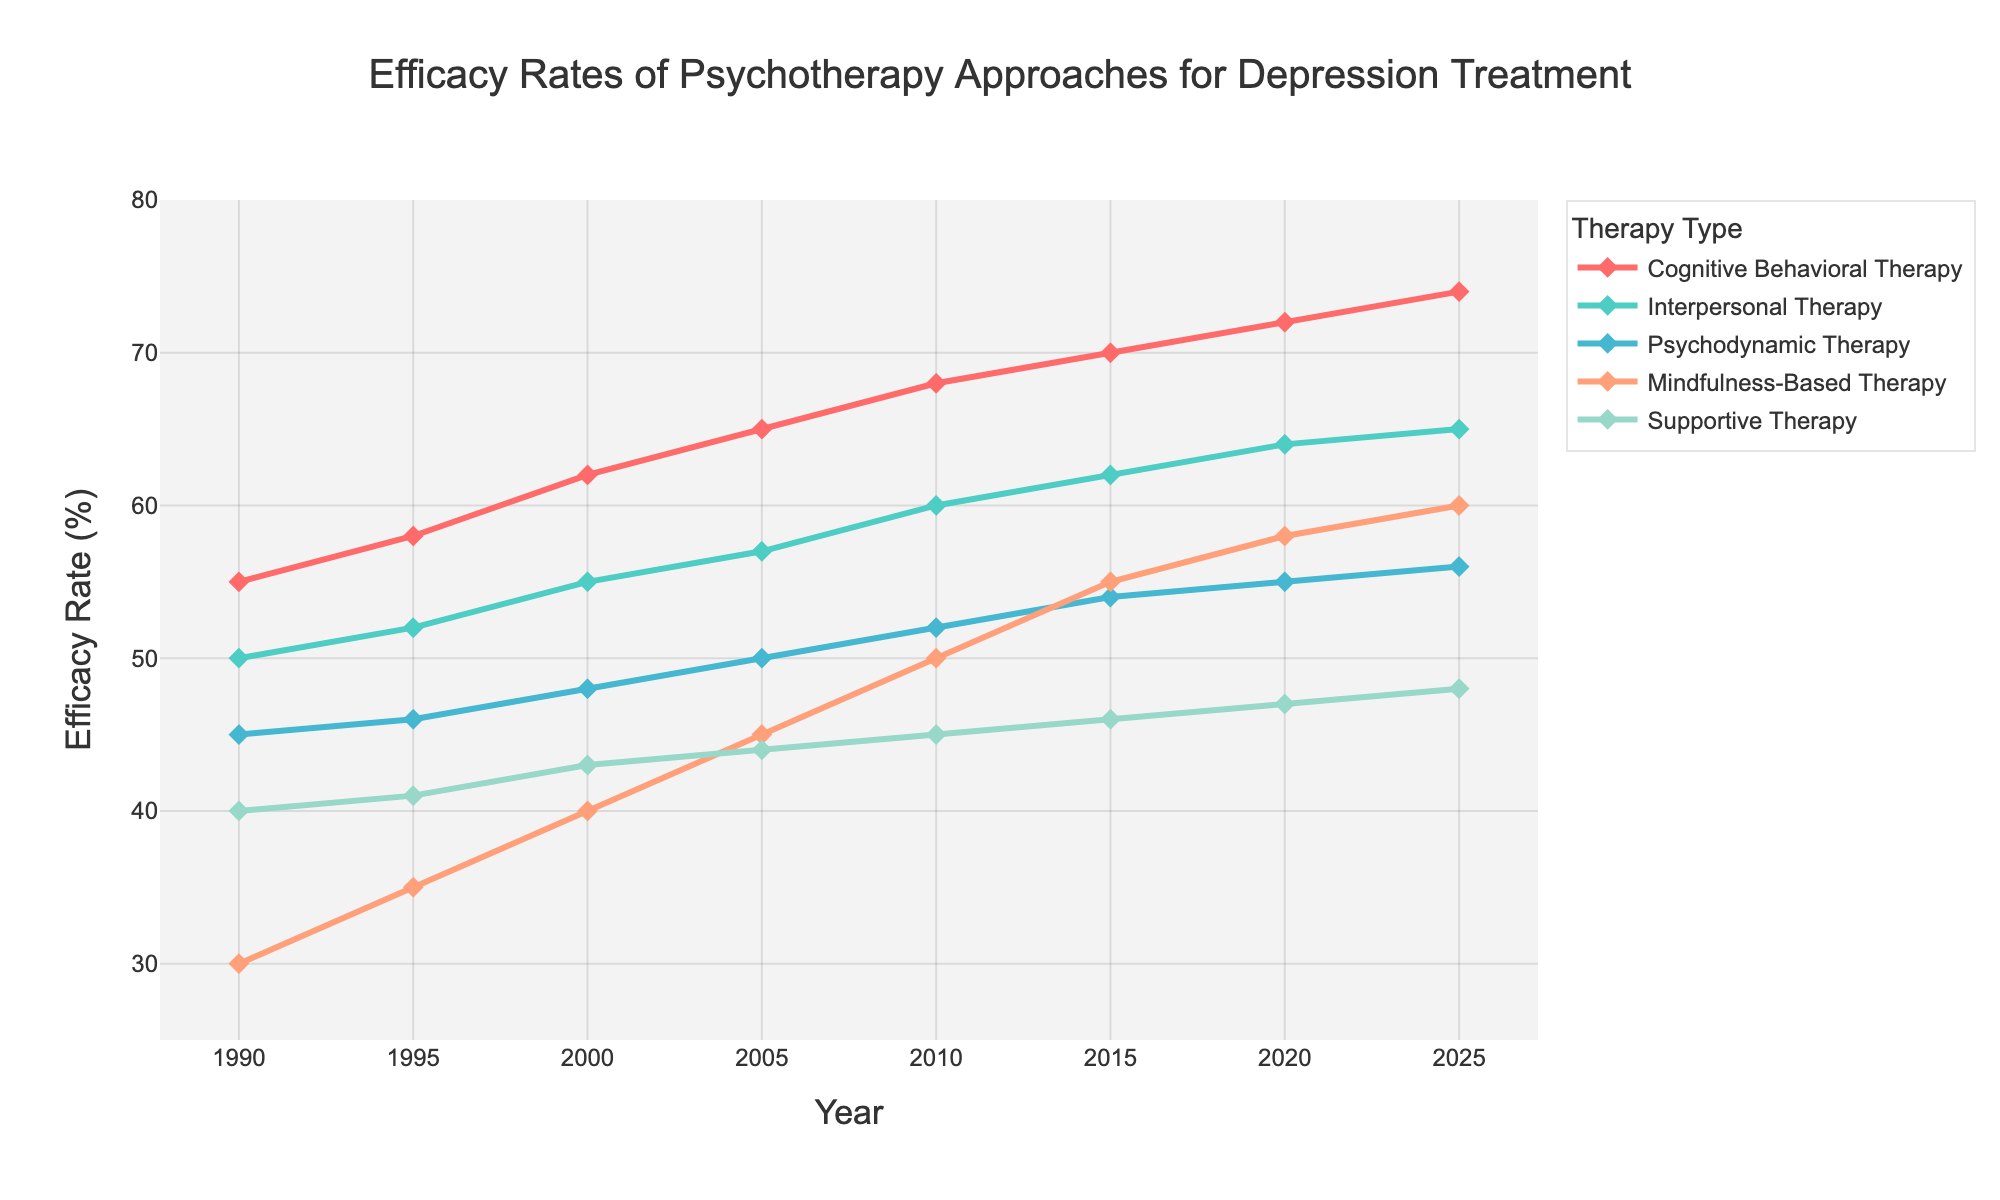What's the average efficacy rate of Cognitive Behavioral Therapy (CBT) over the entire period? First, sum up the efficacy rates of CBT from all the years: 55 + 58 + 62 + 65 + 68 + 70 + 72 + 74 = 524. Then, divide the total by the number of data points: 524 / 8 = 65.5
Answer: 65.5 Which year shows the highest efficacy rate for Mindfulness-Based Therapy? Look at the line for Mindfulness-Based Therapy and identify the peak point which corresponds to the year 2025 with an efficacy rate of 60%.
Answer: 2025 How does the efficacy rate of Interpersonal Therapy in 2000 compare with Psychodynamic Therapy's rate in the same year? Observe the values for Interpersonal Therapy and Psychodynamic Therapy in the year 2000. Interpersonal Therapy is at 55% while Psychodynamic Therapy is at 48%. Interpersonal Therapy is higher.
Answer: Interpersonal Therapy is higher in 2000 Between 1990 and 2025, how much did the efficacy rate of Supportive Therapy increase? Subtract the efficacy rate of Supportive Therapy in 1990 (40%) from that in 2025 (48%): 48 - 40 = 8%.
Answer: 8% In which period did Cognitive Behavioral Therapy see the most significant increase in efficacy? Observe the line representing Cognitive Behavioral Therapy and find the period with the steepest slope. The period from 1990 to 2025 shows a steady increase from 55% to 74%, with the highest increase of 10% happening from 2010 (68%) to 2020 (72%).
Answer: 2010 to 2015 If you average the efficacy rates of 2010 for all therapies, what is the value? Sum the efficacy rates of all therapies in 2010: 68 (CBT) + 60 (Interpersonal) + 52 (Psychodynamic) + 50 (Mindfulness) + 45 (Supportive) = 275. Divide by the number of therapies (5): 275 / 5 = 55%.
Answer: 55% Which therapy has shown consistent improvement without any decline from 1990 to 2025? Observe the lines of all therapies and find the one that continuously increases. Cognitive Behavioral Therapy consistently improves from 1990 to 2025.
Answer: Cognitive Behavioral Therapy Is there any year where Cognitive Behavioral Therapy and Mindfulness-Based Therapy have equal efficacy rates? Compare the values of both therapies year by year. There are no years where their efficacy rates are equal.
Answer: No How does the efficacy rate change for Psychodynamic Therapy from 1990 to 2025? Follow the line representing Psychodynamic Therapy and note the values in 1990 (45%) and 2025 (56%). The change is 56 - 45 = 11%.
Answer: 11% 